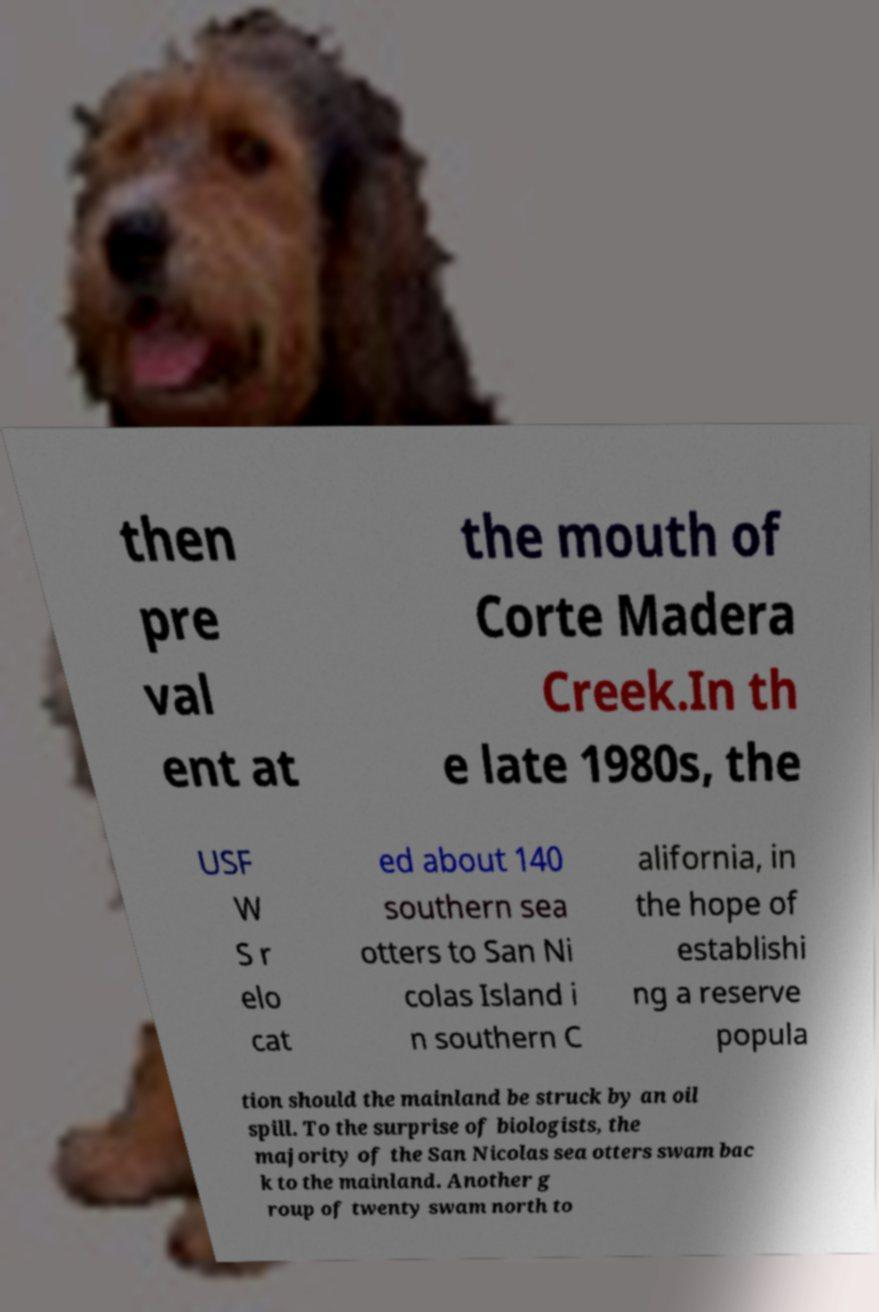There's text embedded in this image that I need extracted. Can you transcribe it verbatim? then pre val ent at the mouth of Corte Madera Creek.In th e late 1980s, the USF W S r elo cat ed about 140 southern sea otters to San Ni colas Island i n southern C alifornia, in the hope of establishi ng a reserve popula tion should the mainland be struck by an oil spill. To the surprise of biologists, the majority of the San Nicolas sea otters swam bac k to the mainland. Another g roup of twenty swam north to 